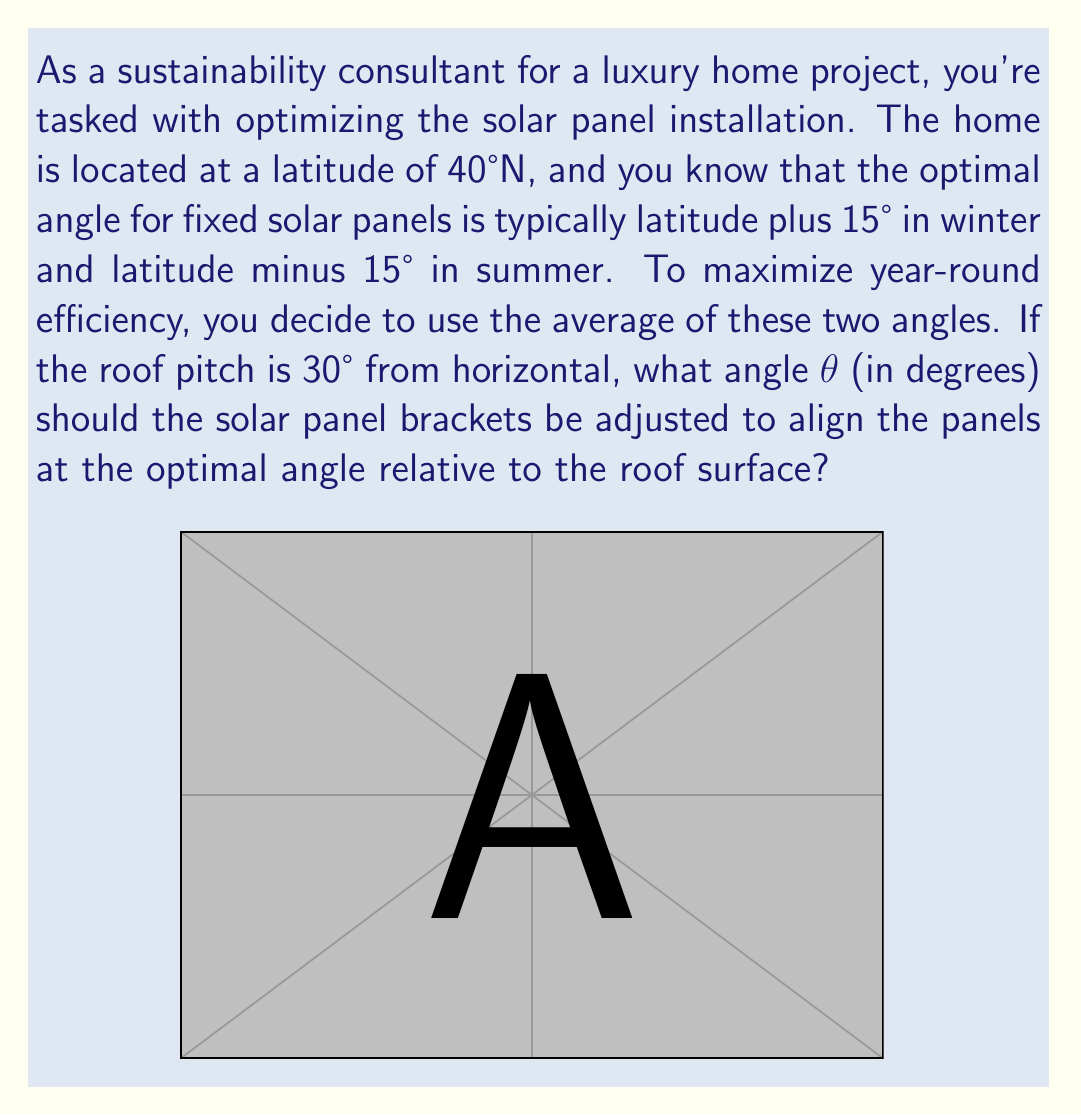Provide a solution to this math problem. Let's approach this step-by-step:

1) First, calculate the optimal angle for the solar panels:
   - Winter angle: $40° + 15° = 55°$
   - Summer angle: $40° - 15° = 25°$
   - Average angle: $\frac{55° + 25°}{2} = 40°$

2) The solar panels need to be at 40° from horizontal, but the roof is already at 30° from horizontal. We need to find the additional angle $\theta$ to add to the roof angle.

3) We can use the angle addition formula for tangent:

   $$\tan(A + B) = \frac{\tan A + \tan B}{1 - \tan A \tan B}$$

   Where $A = 30°$ (roof angle) and $A + B = 40°$ (desired panel angle)

4) Substituting these values:

   $$\tan(40°) = \frac{\tan(30°) + \tan(\theta)}{1 - \tan(30°)\tan(\theta)}$$

5) We know $\tan(40°) \approx 0.8391$ and $\tan(30°) = \frac{1}{\sqrt{3}} \approx 0.5774$

6) Substituting these values and solving for $\tan(\theta)$:

   $$0.8391 = \frac{0.5774 + \tan(\theta)}{1 - 0.5774\tan(\theta)}$$

7) Cross-multiplying and solving the resulting quadratic equation:

   $$0.8391 - 0.4845\tan(\theta) = 0.5774 + \tan(\theta)$$
   $$0.2617 = 1.4845\tan(\theta)$$
   $$\tan(\theta) = 0.1763$$

8) Taking the inverse tangent:

   $$\theta = \tan^{-1}(0.1763) \approx 10.0°$$

Therefore, the solar panel brackets should be adjusted to create an additional 10.0° angle relative to the roof surface.
Answer: $\theta \approx 10.0°$ 